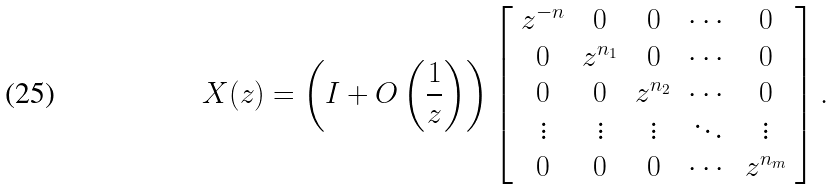Convert formula to latex. <formula><loc_0><loc_0><loc_500><loc_500>X ( z ) = \left ( I + O \left ( \frac { 1 } { z } \right ) \right ) \left [ \begin{array} { c c c c c } z ^ { - n } & 0 & 0 & \cdots & 0 \\ 0 & z ^ { n _ { 1 } } & 0 & \cdots & 0 \\ 0 & 0 & z ^ { n _ { 2 } } & \cdots & 0 \\ \vdots & \vdots & \vdots & \ddots & \vdots \\ 0 & 0 & 0 & \cdots & z ^ { n _ { m } } \end{array} \right ] .</formula> 